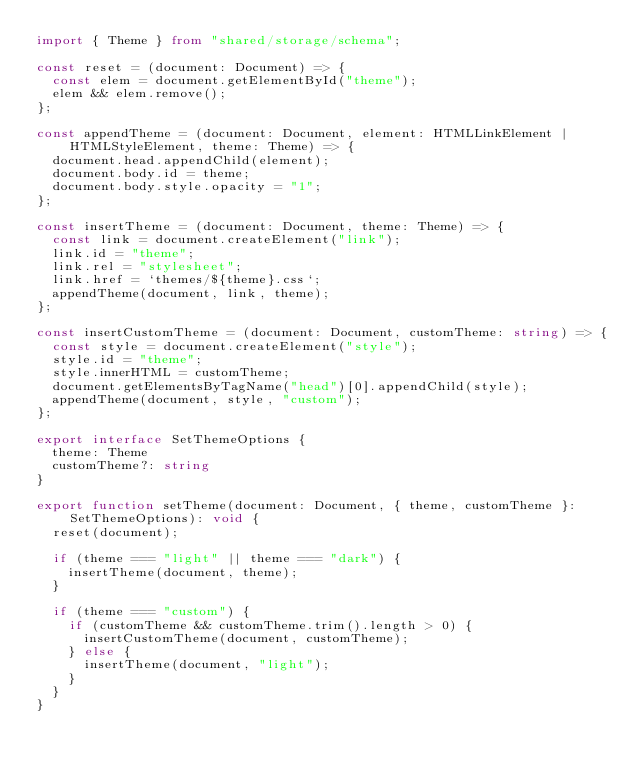Convert code to text. <code><loc_0><loc_0><loc_500><loc_500><_TypeScript_>import { Theme } from "shared/storage/schema";

const reset = (document: Document) => {
  const elem = document.getElementById("theme");
  elem && elem.remove();
};

const appendTheme = (document: Document, element: HTMLLinkElement | HTMLStyleElement, theme: Theme) => {
  document.head.appendChild(element);
  document.body.id = theme;
  document.body.style.opacity = "1";
};

const insertTheme = (document: Document, theme: Theme) => {
  const link = document.createElement("link");
  link.id = "theme";
  link.rel = "stylesheet";
  link.href = `themes/${theme}.css`;
  appendTheme(document, link, theme);
};

const insertCustomTheme = (document: Document, customTheme: string) => {
  const style = document.createElement("style");
  style.id = "theme";
  style.innerHTML = customTheme;
  document.getElementsByTagName("head")[0].appendChild(style);
  appendTheme(document, style, "custom");
};

export interface SetThemeOptions {
  theme: Theme
  customTheme?: string
}

export function setTheme(document: Document, { theme, customTheme }: SetThemeOptions): void {
  reset(document);

  if (theme === "light" || theme === "dark") {
    insertTheme(document, theme);
  }

  if (theme === "custom") {
    if (customTheme && customTheme.trim().length > 0) {
      insertCustomTheme(document, customTheme);
    } else {
      insertTheme(document, "light");
    }
  }
}
</code> 